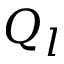Convert formula to latex. <formula><loc_0><loc_0><loc_500><loc_500>Q _ { l }</formula> 